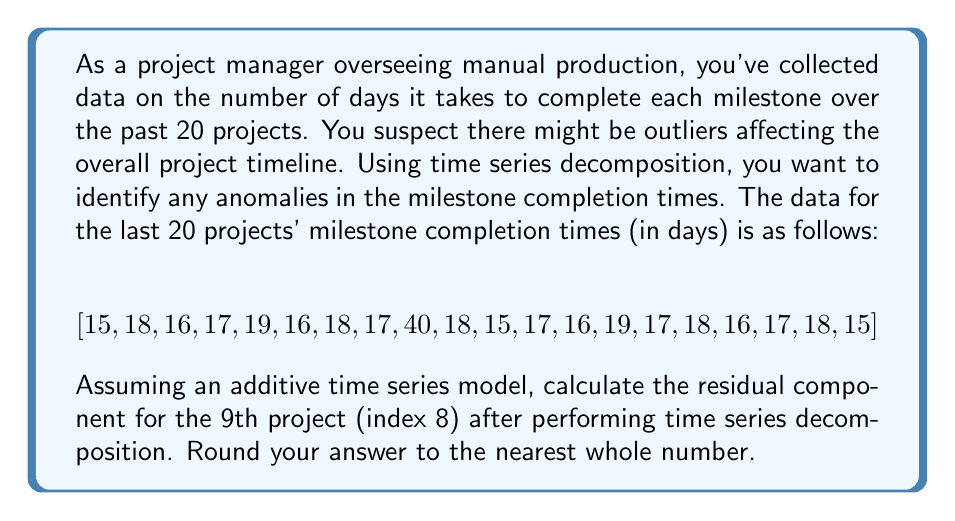What is the answer to this math problem? To solve this problem, we'll follow these steps:

1) First, we need to understand the components of time series decomposition:
   $$Y_t = T_t + S_t + R_t$$
   Where $Y_t$ is the observed value, $T_t$ is the trend component, $S_t$ is the seasonal component, and $R_t$ is the residual component.

2) In this case, we don't have clear seasonality, so we'll focus on the trend and residual components:
   $$Y_t = T_t + R_t$$

3) To estimate the trend component, we'll use a simple moving average. For this example, let's use a 5-point moving average:

   $$T_t = \frac{Y_{t-2} + Y_{t-1} + Y_t + Y_{t+1} + Y_{t+2}}{5}$$

4) Calculate the trend component for the 9th project (index 8):
   $$T_8 = \frac{16 + 18 + 40 + 18 + 15}{5} = 21.4$$

5) Now, we can calculate the residual component by subtracting the trend from the observed value:
   $$R_t = Y_t - T_t$$

   For the 9th project:
   $$R_8 = Y_8 - T_8 = 40 - 21.4 = 18.6$$

6) Rounding to the nearest whole number:
   $$R_8 \approx 19$$

This large positive residual indicates that the 9th project took significantly longer than expected based on the trend, suggesting it's an outlier in the dataset.
Answer: 19 